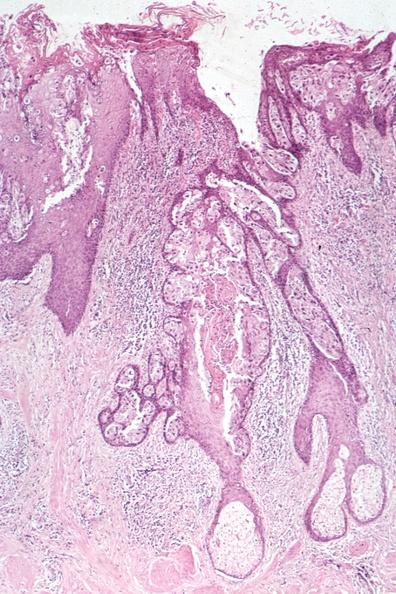s papillary intraductal adenocarcinoma present?
Answer the question using a single word or phrase. No 